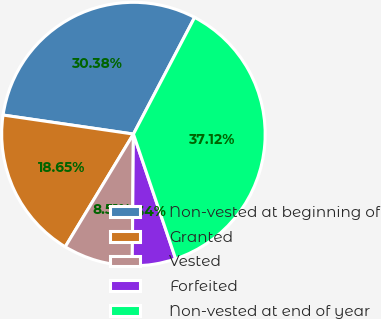<chart> <loc_0><loc_0><loc_500><loc_500><pie_chart><fcel>Non-vested at beginning of<fcel>Granted<fcel>Vested<fcel>Forfeited<fcel>Non-vested at end of year<nl><fcel>30.38%<fcel>18.65%<fcel>8.51%<fcel>5.34%<fcel>37.12%<nl></chart> 